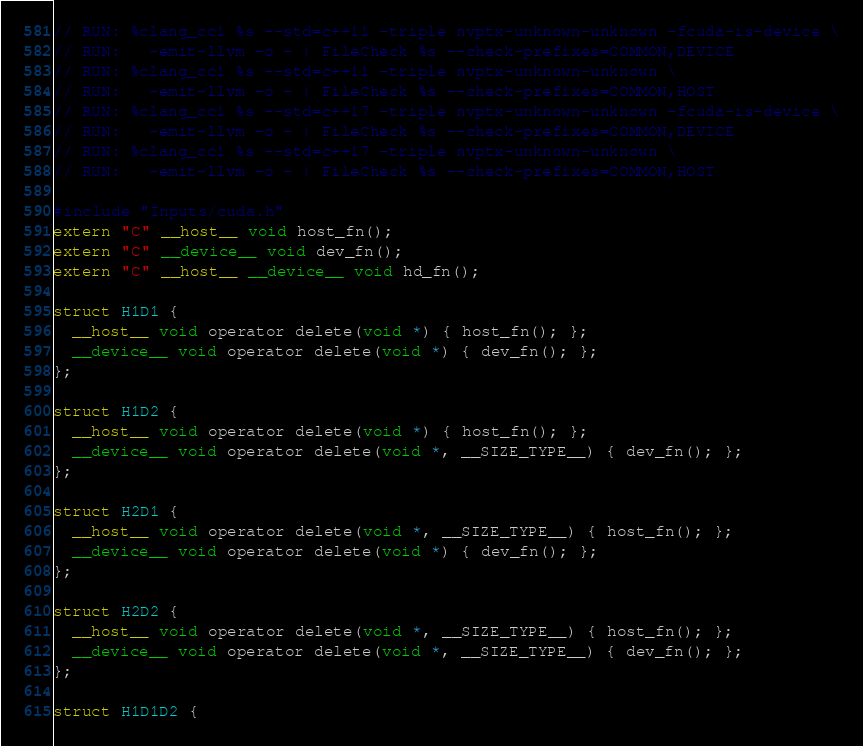<code> <loc_0><loc_0><loc_500><loc_500><_Cuda_>// RUN: %clang_cc1 %s --std=c++11 -triple nvptx-unknown-unknown -fcuda-is-device \
// RUN:   -emit-llvm -o - | FileCheck %s --check-prefixes=COMMON,DEVICE
// RUN: %clang_cc1 %s --std=c++11 -triple nvptx-unknown-unknown \
// RUN:   -emit-llvm -o - | FileCheck %s --check-prefixes=COMMON,HOST
// RUN: %clang_cc1 %s --std=c++17 -triple nvptx-unknown-unknown -fcuda-is-device \
// RUN:   -emit-llvm -o - | FileCheck %s --check-prefixes=COMMON,DEVICE
// RUN: %clang_cc1 %s --std=c++17 -triple nvptx-unknown-unknown \
// RUN:   -emit-llvm -o - | FileCheck %s --check-prefixes=COMMON,HOST

#include "Inputs/cuda.h"
extern "C" __host__ void host_fn();
extern "C" __device__ void dev_fn();
extern "C" __host__ __device__ void hd_fn();

struct H1D1 {
  __host__ void operator delete(void *) { host_fn(); };
  __device__ void operator delete(void *) { dev_fn(); };
};

struct H1D2 {
  __host__ void operator delete(void *) { host_fn(); };
  __device__ void operator delete(void *, __SIZE_TYPE__) { dev_fn(); };
};

struct H2D1 {
  __host__ void operator delete(void *, __SIZE_TYPE__) { host_fn(); };
  __device__ void operator delete(void *) { dev_fn(); };
};

struct H2D2 {
  __host__ void operator delete(void *, __SIZE_TYPE__) { host_fn(); };
  __device__ void operator delete(void *, __SIZE_TYPE__) { dev_fn(); };
};

struct H1D1D2 {</code> 